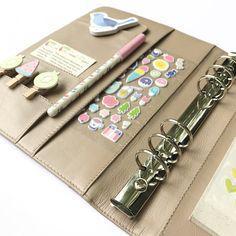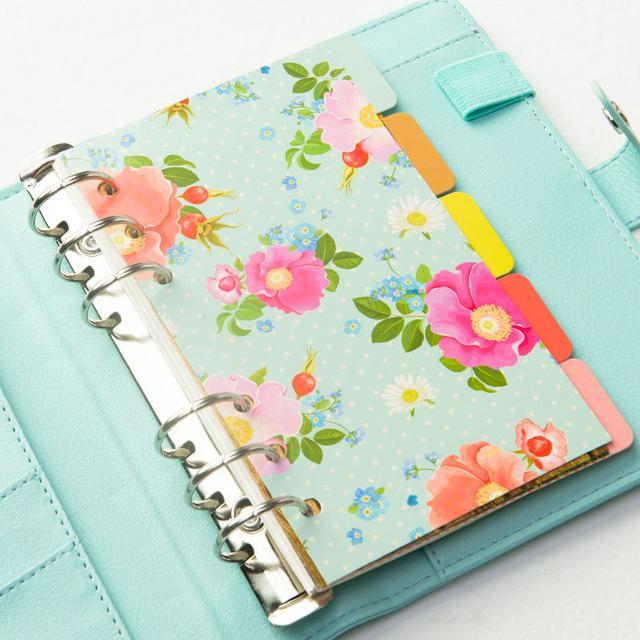The first image is the image on the left, the second image is the image on the right. Given the left and right images, does the statement "One image shows exactly one open orange binder." hold true? Answer yes or no. No. The first image is the image on the left, the second image is the image on the right. Evaluate the accuracy of this statement regarding the images: "In one image, a peach colored notebook is shown in an open position, displaying its contents.". Is it true? Answer yes or no. No. 